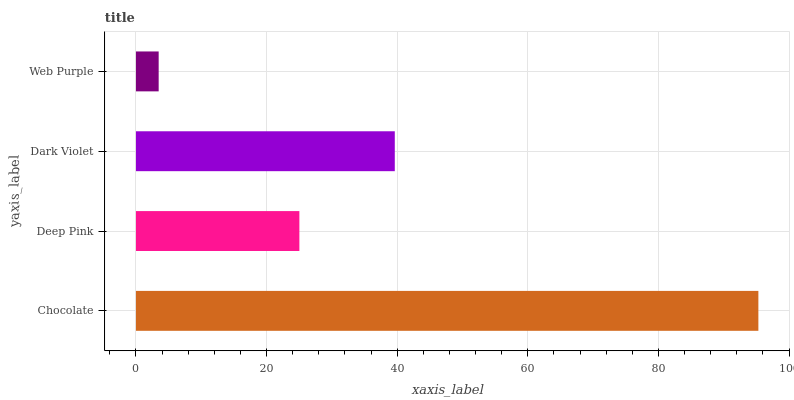Is Web Purple the minimum?
Answer yes or no. Yes. Is Chocolate the maximum?
Answer yes or no. Yes. Is Deep Pink the minimum?
Answer yes or no. No. Is Deep Pink the maximum?
Answer yes or no. No. Is Chocolate greater than Deep Pink?
Answer yes or no. Yes. Is Deep Pink less than Chocolate?
Answer yes or no. Yes. Is Deep Pink greater than Chocolate?
Answer yes or no. No. Is Chocolate less than Deep Pink?
Answer yes or no. No. Is Dark Violet the high median?
Answer yes or no. Yes. Is Deep Pink the low median?
Answer yes or no. Yes. Is Web Purple the high median?
Answer yes or no. No. Is Dark Violet the low median?
Answer yes or no. No. 